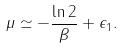Convert formula to latex. <formula><loc_0><loc_0><loc_500><loc_500>\mu \simeq - \frac { \ln 2 } { \beta } + \epsilon _ { 1 } .</formula> 